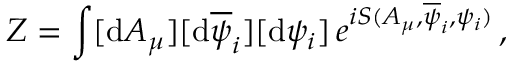<formula> <loc_0><loc_0><loc_500><loc_500>Z = \int [ d A _ { \mu } ] [ d \overline { \psi } _ { i } ] [ d \psi _ { i } ] \, e ^ { i S ( A _ { \mu } , \overline { \psi } _ { i } , \psi _ { i } ) } \, ,</formula> 